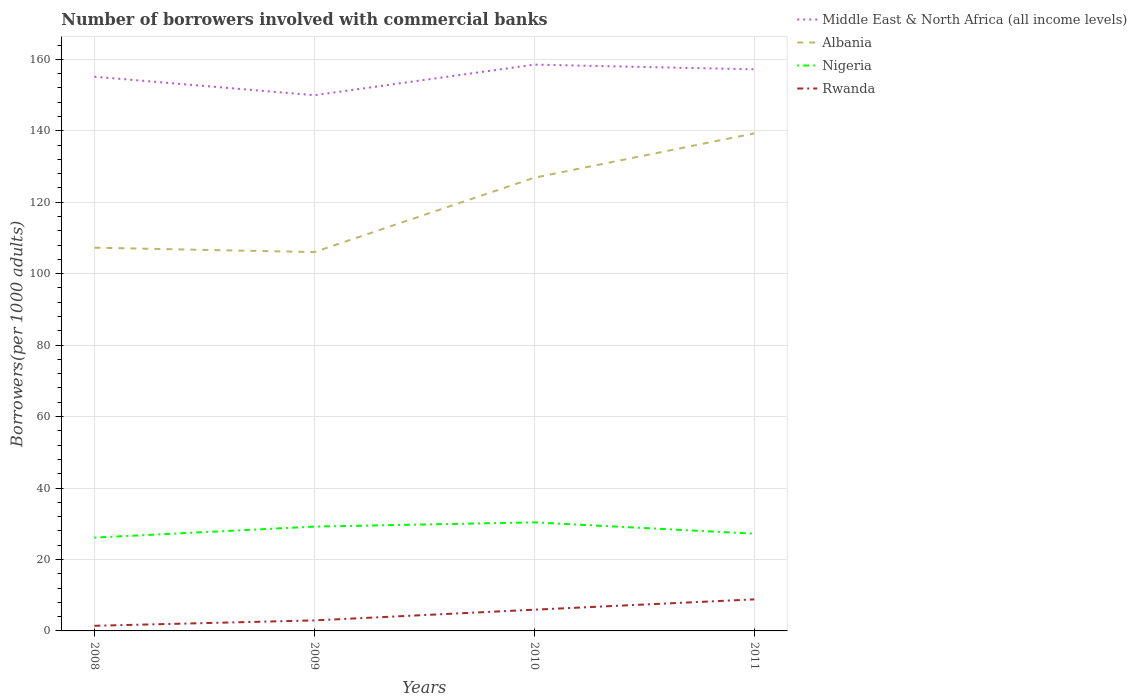Across all years, what is the maximum number of borrowers involved with commercial banks in Rwanda?
Provide a succinct answer. 1.44. In which year was the number of borrowers involved with commercial banks in Rwanda maximum?
Your answer should be very brief. 2008. What is the total number of borrowers involved with commercial banks in Albania in the graph?
Give a very brief answer. -12.4. What is the difference between the highest and the second highest number of borrowers involved with commercial banks in Nigeria?
Give a very brief answer. 4.27. How many years are there in the graph?
Keep it short and to the point. 4. Are the values on the major ticks of Y-axis written in scientific E-notation?
Your answer should be very brief. No. Does the graph contain any zero values?
Give a very brief answer. No. Does the graph contain grids?
Provide a succinct answer. Yes. Where does the legend appear in the graph?
Your answer should be compact. Top right. What is the title of the graph?
Your answer should be compact. Number of borrowers involved with commercial banks. What is the label or title of the X-axis?
Give a very brief answer. Years. What is the label or title of the Y-axis?
Your answer should be very brief. Borrowers(per 1000 adults). What is the Borrowers(per 1000 adults) of Middle East & North Africa (all income levels) in 2008?
Give a very brief answer. 155.14. What is the Borrowers(per 1000 adults) of Albania in 2008?
Offer a very short reply. 107.27. What is the Borrowers(per 1000 adults) in Nigeria in 2008?
Your answer should be very brief. 26.12. What is the Borrowers(per 1000 adults) of Rwanda in 2008?
Make the answer very short. 1.44. What is the Borrowers(per 1000 adults) of Middle East & North Africa (all income levels) in 2009?
Ensure brevity in your answer.  149.95. What is the Borrowers(per 1000 adults) in Albania in 2009?
Provide a short and direct response. 106.05. What is the Borrowers(per 1000 adults) of Nigeria in 2009?
Your answer should be very brief. 29.2. What is the Borrowers(per 1000 adults) of Rwanda in 2009?
Your answer should be compact. 2.94. What is the Borrowers(per 1000 adults) of Middle East & North Africa (all income levels) in 2010?
Offer a terse response. 158.51. What is the Borrowers(per 1000 adults) of Albania in 2010?
Your answer should be compact. 126.87. What is the Borrowers(per 1000 adults) of Nigeria in 2010?
Give a very brief answer. 30.39. What is the Borrowers(per 1000 adults) of Rwanda in 2010?
Your answer should be compact. 5.94. What is the Borrowers(per 1000 adults) of Middle East & North Africa (all income levels) in 2011?
Offer a terse response. 157.2. What is the Borrowers(per 1000 adults) of Albania in 2011?
Your answer should be compact. 139.27. What is the Borrowers(per 1000 adults) of Nigeria in 2011?
Give a very brief answer. 27.21. What is the Borrowers(per 1000 adults) in Rwanda in 2011?
Your answer should be compact. 8.83. Across all years, what is the maximum Borrowers(per 1000 adults) in Middle East & North Africa (all income levels)?
Provide a short and direct response. 158.51. Across all years, what is the maximum Borrowers(per 1000 adults) in Albania?
Offer a very short reply. 139.27. Across all years, what is the maximum Borrowers(per 1000 adults) of Nigeria?
Give a very brief answer. 30.39. Across all years, what is the maximum Borrowers(per 1000 adults) of Rwanda?
Provide a succinct answer. 8.83. Across all years, what is the minimum Borrowers(per 1000 adults) in Middle East & North Africa (all income levels)?
Offer a very short reply. 149.95. Across all years, what is the minimum Borrowers(per 1000 adults) of Albania?
Keep it short and to the point. 106.05. Across all years, what is the minimum Borrowers(per 1000 adults) of Nigeria?
Your answer should be compact. 26.12. Across all years, what is the minimum Borrowers(per 1000 adults) of Rwanda?
Your answer should be very brief. 1.44. What is the total Borrowers(per 1000 adults) in Middle East & North Africa (all income levels) in the graph?
Make the answer very short. 620.8. What is the total Borrowers(per 1000 adults) in Albania in the graph?
Ensure brevity in your answer.  479.45. What is the total Borrowers(per 1000 adults) in Nigeria in the graph?
Ensure brevity in your answer.  112.92. What is the total Borrowers(per 1000 adults) of Rwanda in the graph?
Offer a terse response. 19.15. What is the difference between the Borrowers(per 1000 adults) of Middle East & North Africa (all income levels) in 2008 and that in 2009?
Offer a very short reply. 5.19. What is the difference between the Borrowers(per 1000 adults) in Albania in 2008 and that in 2009?
Ensure brevity in your answer.  1.23. What is the difference between the Borrowers(per 1000 adults) in Nigeria in 2008 and that in 2009?
Keep it short and to the point. -3.08. What is the difference between the Borrowers(per 1000 adults) in Rwanda in 2008 and that in 2009?
Make the answer very short. -1.51. What is the difference between the Borrowers(per 1000 adults) in Middle East & North Africa (all income levels) in 2008 and that in 2010?
Offer a terse response. -3.38. What is the difference between the Borrowers(per 1000 adults) in Albania in 2008 and that in 2010?
Provide a succinct answer. -19.59. What is the difference between the Borrowers(per 1000 adults) of Nigeria in 2008 and that in 2010?
Make the answer very short. -4.27. What is the difference between the Borrowers(per 1000 adults) in Rwanda in 2008 and that in 2010?
Give a very brief answer. -4.51. What is the difference between the Borrowers(per 1000 adults) of Middle East & North Africa (all income levels) in 2008 and that in 2011?
Keep it short and to the point. -2.06. What is the difference between the Borrowers(per 1000 adults) in Albania in 2008 and that in 2011?
Ensure brevity in your answer.  -31.99. What is the difference between the Borrowers(per 1000 adults) in Nigeria in 2008 and that in 2011?
Make the answer very short. -1.09. What is the difference between the Borrowers(per 1000 adults) in Rwanda in 2008 and that in 2011?
Your answer should be very brief. -7.39. What is the difference between the Borrowers(per 1000 adults) in Middle East & North Africa (all income levels) in 2009 and that in 2010?
Make the answer very short. -8.56. What is the difference between the Borrowers(per 1000 adults) of Albania in 2009 and that in 2010?
Offer a very short reply. -20.82. What is the difference between the Borrowers(per 1000 adults) in Nigeria in 2009 and that in 2010?
Offer a very short reply. -1.19. What is the difference between the Borrowers(per 1000 adults) of Rwanda in 2009 and that in 2010?
Ensure brevity in your answer.  -3. What is the difference between the Borrowers(per 1000 adults) in Middle East & North Africa (all income levels) in 2009 and that in 2011?
Your response must be concise. -7.25. What is the difference between the Borrowers(per 1000 adults) in Albania in 2009 and that in 2011?
Your answer should be very brief. -33.22. What is the difference between the Borrowers(per 1000 adults) in Nigeria in 2009 and that in 2011?
Give a very brief answer. 1.98. What is the difference between the Borrowers(per 1000 adults) of Rwanda in 2009 and that in 2011?
Offer a very short reply. -5.89. What is the difference between the Borrowers(per 1000 adults) in Middle East & North Africa (all income levels) in 2010 and that in 2011?
Provide a succinct answer. 1.32. What is the difference between the Borrowers(per 1000 adults) of Albania in 2010 and that in 2011?
Provide a short and direct response. -12.4. What is the difference between the Borrowers(per 1000 adults) of Nigeria in 2010 and that in 2011?
Offer a very short reply. 3.17. What is the difference between the Borrowers(per 1000 adults) in Rwanda in 2010 and that in 2011?
Keep it short and to the point. -2.89. What is the difference between the Borrowers(per 1000 adults) in Middle East & North Africa (all income levels) in 2008 and the Borrowers(per 1000 adults) in Albania in 2009?
Provide a short and direct response. 49.09. What is the difference between the Borrowers(per 1000 adults) of Middle East & North Africa (all income levels) in 2008 and the Borrowers(per 1000 adults) of Nigeria in 2009?
Offer a very short reply. 125.94. What is the difference between the Borrowers(per 1000 adults) in Middle East & North Africa (all income levels) in 2008 and the Borrowers(per 1000 adults) in Rwanda in 2009?
Your response must be concise. 152.19. What is the difference between the Borrowers(per 1000 adults) in Albania in 2008 and the Borrowers(per 1000 adults) in Nigeria in 2009?
Ensure brevity in your answer.  78.08. What is the difference between the Borrowers(per 1000 adults) of Albania in 2008 and the Borrowers(per 1000 adults) of Rwanda in 2009?
Your response must be concise. 104.33. What is the difference between the Borrowers(per 1000 adults) of Nigeria in 2008 and the Borrowers(per 1000 adults) of Rwanda in 2009?
Offer a terse response. 23.18. What is the difference between the Borrowers(per 1000 adults) of Middle East & North Africa (all income levels) in 2008 and the Borrowers(per 1000 adults) of Albania in 2010?
Provide a short and direct response. 28.27. What is the difference between the Borrowers(per 1000 adults) of Middle East & North Africa (all income levels) in 2008 and the Borrowers(per 1000 adults) of Nigeria in 2010?
Provide a short and direct response. 124.75. What is the difference between the Borrowers(per 1000 adults) in Middle East & North Africa (all income levels) in 2008 and the Borrowers(per 1000 adults) in Rwanda in 2010?
Give a very brief answer. 149.19. What is the difference between the Borrowers(per 1000 adults) in Albania in 2008 and the Borrowers(per 1000 adults) in Nigeria in 2010?
Provide a short and direct response. 76.89. What is the difference between the Borrowers(per 1000 adults) in Albania in 2008 and the Borrowers(per 1000 adults) in Rwanda in 2010?
Give a very brief answer. 101.33. What is the difference between the Borrowers(per 1000 adults) of Nigeria in 2008 and the Borrowers(per 1000 adults) of Rwanda in 2010?
Give a very brief answer. 20.18. What is the difference between the Borrowers(per 1000 adults) in Middle East & North Africa (all income levels) in 2008 and the Borrowers(per 1000 adults) in Albania in 2011?
Ensure brevity in your answer.  15.87. What is the difference between the Borrowers(per 1000 adults) in Middle East & North Africa (all income levels) in 2008 and the Borrowers(per 1000 adults) in Nigeria in 2011?
Your answer should be very brief. 127.92. What is the difference between the Borrowers(per 1000 adults) in Middle East & North Africa (all income levels) in 2008 and the Borrowers(per 1000 adults) in Rwanda in 2011?
Your response must be concise. 146.31. What is the difference between the Borrowers(per 1000 adults) in Albania in 2008 and the Borrowers(per 1000 adults) in Nigeria in 2011?
Make the answer very short. 80.06. What is the difference between the Borrowers(per 1000 adults) in Albania in 2008 and the Borrowers(per 1000 adults) in Rwanda in 2011?
Provide a short and direct response. 98.44. What is the difference between the Borrowers(per 1000 adults) of Nigeria in 2008 and the Borrowers(per 1000 adults) of Rwanda in 2011?
Your response must be concise. 17.29. What is the difference between the Borrowers(per 1000 adults) in Middle East & North Africa (all income levels) in 2009 and the Borrowers(per 1000 adults) in Albania in 2010?
Offer a very short reply. 23.08. What is the difference between the Borrowers(per 1000 adults) in Middle East & North Africa (all income levels) in 2009 and the Borrowers(per 1000 adults) in Nigeria in 2010?
Offer a terse response. 119.56. What is the difference between the Borrowers(per 1000 adults) of Middle East & North Africa (all income levels) in 2009 and the Borrowers(per 1000 adults) of Rwanda in 2010?
Offer a very short reply. 144.01. What is the difference between the Borrowers(per 1000 adults) in Albania in 2009 and the Borrowers(per 1000 adults) in Nigeria in 2010?
Your answer should be compact. 75.66. What is the difference between the Borrowers(per 1000 adults) of Albania in 2009 and the Borrowers(per 1000 adults) of Rwanda in 2010?
Your response must be concise. 100.1. What is the difference between the Borrowers(per 1000 adults) in Nigeria in 2009 and the Borrowers(per 1000 adults) in Rwanda in 2010?
Provide a short and direct response. 23.25. What is the difference between the Borrowers(per 1000 adults) in Middle East & North Africa (all income levels) in 2009 and the Borrowers(per 1000 adults) in Albania in 2011?
Provide a succinct answer. 10.68. What is the difference between the Borrowers(per 1000 adults) of Middle East & North Africa (all income levels) in 2009 and the Borrowers(per 1000 adults) of Nigeria in 2011?
Give a very brief answer. 122.73. What is the difference between the Borrowers(per 1000 adults) of Middle East & North Africa (all income levels) in 2009 and the Borrowers(per 1000 adults) of Rwanda in 2011?
Your response must be concise. 141.12. What is the difference between the Borrowers(per 1000 adults) in Albania in 2009 and the Borrowers(per 1000 adults) in Nigeria in 2011?
Provide a succinct answer. 78.83. What is the difference between the Borrowers(per 1000 adults) of Albania in 2009 and the Borrowers(per 1000 adults) of Rwanda in 2011?
Give a very brief answer. 97.22. What is the difference between the Borrowers(per 1000 adults) in Nigeria in 2009 and the Borrowers(per 1000 adults) in Rwanda in 2011?
Your answer should be compact. 20.37. What is the difference between the Borrowers(per 1000 adults) of Middle East & North Africa (all income levels) in 2010 and the Borrowers(per 1000 adults) of Albania in 2011?
Give a very brief answer. 19.25. What is the difference between the Borrowers(per 1000 adults) in Middle East & North Africa (all income levels) in 2010 and the Borrowers(per 1000 adults) in Nigeria in 2011?
Offer a very short reply. 131.3. What is the difference between the Borrowers(per 1000 adults) in Middle East & North Africa (all income levels) in 2010 and the Borrowers(per 1000 adults) in Rwanda in 2011?
Give a very brief answer. 149.68. What is the difference between the Borrowers(per 1000 adults) in Albania in 2010 and the Borrowers(per 1000 adults) in Nigeria in 2011?
Provide a short and direct response. 99.65. What is the difference between the Borrowers(per 1000 adults) in Albania in 2010 and the Borrowers(per 1000 adults) in Rwanda in 2011?
Offer a terse response. 118.04. What is the difference between the Borrowers(per 1000 adults) in Nigeria in 2010 and the Borrowers(per 1000 adults) in Rwanda in 2011?
Your answer should be compact. 21.56. What is the average Borrowers(per 1000 adults) in Middle East & North Africa (all income levels) per year?
Your answer should be very brief. 155.2. What is the average Borrowers(per 1000 adults) in Albania per year?
Ensure brevity in your answer.  119.86. What is the average Borrowers(per 1000 adults) in Nigeria per year?
Your response must be concise. 28.23. What is the average Borrowers(per 1000 adults) of Rwanda per year?
Your answer should be very brief. 4.79. In the year 2008, what is the difference between the Borrowers(per 1000 adults) in Middle East & North Africa (all income levels) and Borrowers(per 1000 adults) in Albania?
Your response must be concise. 47.86. In the year 2008, what is the difference between the Borrowers(per 1000 adults) of Middle East & North Africa (all income levels) and Borrowers(per 1000 adults) of Nigeria?
Your answer should be very brief. 129.02. In the year 2008, what is the difference between the Borrowers(per 1000 adults) of Middle East & North Africa (all income levels) and Borrowers(per 1000 adults) of Rwanda?
Make the answer very short. 153.7. In the year 2008, what is the difference between the Borrowers(per 1000 adults) in Albania and Borrowers(per 1000 adults) in Nigeria?
Offer a terse response. 81.15. In the year 2008, what is the difference between the Borrowers(per 1000 adults) in Albania and Borrowers(per 1000 adults) in Rwanda?
Make the answer very short. 105.84. In the year 2008, what is the difference between the Borrowers(per 1000 adults) in Nigeria and Borrowers(per 1000 adults) in Rwanda?
Give a very brief answer. 24.68. In the year 2009, what is the difference between the Borrowers(per 1000 adults) in Middle East & North Africa (all income levels) and Borrowers(per 1000 adults) in Albania?
Provide a succinct answer. 43.9. In the year 2009, what is the difference between the Borrowers(per 1000 adults) of Middle East & North Africa (all income levels) and Borrowers(per 1000 adults) of Nigeria?
Your answer should be very brief. 120.75. In the year 2009, what is the difference between the Borrowers(per 1000 adults) of Middle East & North Africa (all income levels) and Borrowers(per 1000 adults) of Rwanda?
Offer a very short reply. 147.01. In the year 2009, what is the difference between the Borrowers(per 1000 adults) in Albania and Borrowers(per 1000 adults) in Nigeria?
Keep it short and to the point. 76.85. In the year 2009, what is the difference between the Borrowers(per 1000 adults) of Albania and Borrowers(per 1000 adults) of Rwanda?
Give a very brief answer. 103.1. In the year 2009, what is the difference between the Borrowers(per 1000 adults) of Nigeria and Borrowers(per 1000 adults) of Rwanda?
Keep it short and to the point. 26.25. In the year 2010, what is the difference between the Borrowers(per 1000 adults) of Middle East & North Africa (all income levels) and Borrowers(per 1000 adults) of Albania?
Make the answer very short. 31.65. In the year 2010, what is the difference between the Borrowers(per 1000 adults) of Middle East & North Africa (all income levels) and Borrowers(per 1000 adults) of Nigeria?
Your answer should be very brief. 128.13. In the year 2010, what is the difference between the Borrowers(per 1000 adults) of Middle East & North Africa (all income levels) and Borrowers(per 1000 adults) of Rwanda?
Make the answer very short. 152.57. In the year 2010, what is the difference between the Borrowers(per 1000 adults) in Albania and Borrowers(per 1000 adults) in Nigeria?
Ensure brevity in your answer.  96.48. In the year 2010, what is the difference between the Borrowers(per 1000 adults) in Albania and Borrowers(per 1000 adults) in Rwanda?
Make the answer very short. 120.92. In the year 2010, what is the difference between the Borrowers(per 1000 adults) in Nigeria and Borrowers(per 1000 adults) in Rwanda?
Keep it short and to the point. 24.44. In the year 2011, what is the difference between the Borrowers(per 1000 adults) in Middle East & North Africa (all income levels) and Borrowers(per 1000 adults) in Albania?
Offer a very short reply. 17.93. In the year 2011, what is the difference between the Borrowers(per 1000 adults) in Middle East & North Africa (all income levels) and Borrowers(per 1000 adults) in Nigeria?
Your answer should be compact. 129.98. In the year 2011, what is the difference between the Borrowers(per 1000 adults) of Middle East & North Africa (all income levels) and Borrowers(per 1000 adults) of Rwanda?
Make the answer very short. 148.37. In the year 2011, what is the difference between the Borrowers(per 1000 adults) of Albania and Borrowers(per 1000 adults) of Nigeria?
Your response must be concise. 112.05. In the year 2011, what is the difference between the Borrowers(per 1000 adults) in Albania and Borrowers(per 1000 adults) in Rwanda?
Your response must be concise. 130.44. In the year 2011, what is the difference between the Borrowers(per 1000 adults) of Nigeria and Borrowers(per 1000 adults) of Rwanda?
Your answer should be very brief. 18.38. What is the ratio of the Borrowers(per 1000 adults) in Middle East & North Africa (all income levels) in 2008 to that in 2009?
Provide a short and direct response. 1.03. What is the ratio of the Borrowers(per 1000 adults) of Albania in 2008 to that in 2009?
Ensure brevity in your answer.  1.01. What is the ratio of the Borrowers(per 1000 adults) in Nigeria in 2008 to that in 2009?
Your answer should be very brief. 0.89. What is the ratio of the Borrowers(per 1000 adults) in Rwanda in 2008 to that in 2009?
Provide a short and direct response. 0.49. What is the ratio of the Borrowers(per 1000 adults) of Middle East & North Africa (all income levels) in 2008 to that in 2010?
Make the answer very short. 0.98. What is the ratio of the Borrowers(per 1000 adults) in Albania in 2008 to that in 2010?
Offer a very short reply. 0.85. What is the ratio of the Borrowers(per 1000 adults) in Nigeria in 2008 to that in 2010?
Your answer should be very brief. 0.86. What is the ratio of the Borrowers(per 1000 adults) of Rwanda in 2008 to that in 2010?
Provide a succinct answer. 0.24. What is the ratio of the Borrowers(per 1000 adults) in Middle East & North Africa (all income levels) in 2008 to that in 2011?
Provide a succinct answer. 0.99. What is the ratio of the Borrowers(per 1000 adults) of Albania in 2008 to that in 2011?
Provide a succinct answer. 0.77. What is the ratio of the Borrowers(per 1000 adults) in Nigeria in 2008 to that in 2011?
Provide a succinct answer. 0.96. What is the ratio of the Borrowers(per 1000 adults) of Rwanda in 2008 to that in 2011?
Provide a short and direct response. 0.16. What is the ratio of the Borrowers(per 1000 adults) of Middle East & North Africa (all income levels) in 2009 to that in 2010?
Offer a terse response. 0.95. What is the ratio of the Borrowers(per 1000 adults) of Albania in 2009 to that in 2010?
Offer a terse response. 0.84. What is the ratio of the Borrowers(per 1000 adults) of Nigeria in 2009 to that in 2010?
Ensure brevity in your answer.  0.96. What is the ratio of the Borrowers(per 1000 adults) in Rwanda in 2009 to that in 2010?
Your answer should be compact. 0.5. What is the ratio of the Borrowers(per 1000 adults) of Middle East & North Africa (all income levels) in 2009 to that in 2011?
Make the answer very short. 0.95. What is the ratio of the Borrowers(per 1000 adults) of Albania in 2009 to that in 2011?
Give a very brief answer. 0.76. What is the ratio of the Borrowers(per 1000 adults) in Nigeria in 2009 to that in 2011?
Offer a very short reply. 1.07. What is the ratio of the Borrowers(per 1000 adults) of Rwanda in 2009 to that in 2011?
Your response must be concise. 0.33. What is the ratio of the Borrowers(per 1000 adults) in Middle East & North Africa (all income levels) in 2010 to that in 2011?
Your response must be concise. 1.01. What is the ratio of the Borrowers(per 1000 adults) in Albania in 2010 to that in 2011?
Give a very brief answer. 0.91. What is the ratio of the Borrowers(per 1000 adults) of Nigeria in 2010 to that in 2011?
Offer a terse response. 1.12. What is the ratio of the Borrowers(per 1000 adults) of Rwanda in 2010 to that in 2011?
Your answer should be compact. 0.67. What is the difference between the highest and the second highest Borrowers(per 1000 adults) in Middle East & North Africa (all income levels)?
Ensure brevity in your answer.  1.32. What is the difference between the highest and the second highest Borrowers(per 1000 adults) in Albania?
Make the answer very short. 12.4. What is the difference between the highest and the second highest Borrowers(per 1000 adults) of Nigeria?
Make the answer very short. 1.19. What is the difference between the highest and the second highest Borrowers(per 1000 adults) in Rwanda?
Make the answer very short. 2.89. What is the difference between the highest and the lowest Borrowers(per 1000 adults) in Middle East & North Africa (all income levels)?
Your answer should be very brief. 8.56. What is the difference between the highest and the lowest Borrowers(per 1000 adults) in Albania?
Make the answer very short. 33.22. What is the difference between the highest and the lowest Borrowers(per 1000 adults) in Nigeria?
Provide a succinct answer. 4.27. What is the difference between the highest and the lowest Borrowers(per 1000 adults) of Rwanda?
Provide a short and direct response. 7.39. 